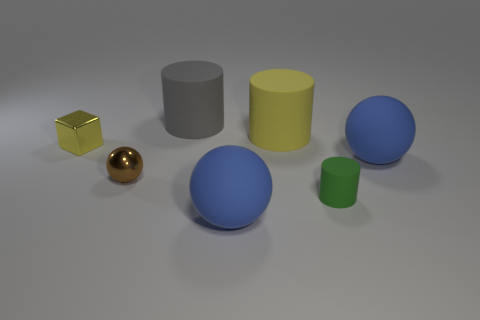The object that is the same color as the block is what size?
Make the answer very short. Large. Is there anything else that is the same size as the brown thing?
Your response must be concise. Yes. Is the tiny brown ball made of the same material as the green cylinder?
Provide a short and direct response. No. What number of objects are either big matte spheres that are behind the tiny green matte cylinder or small objects that are to the left of the gray rubber object?
Give a very brief answer. 3. Is there a cyan metal cylinder that has the same size as the green rubber object?
Give a very brief answer. No. There is a small thing that is the same shape as the large yellow rubber thing; what color is it?
Your answer should be compact. Green. Is there a tiny yellow metallic cube in front of the big blue rubber sphere in front of the metallic sphere?
Your response must be concise. No. There is a object in front of the small matte thing; does it have the same shape as the tiny green matte thing?
Ensure brevity in your answer.  No. What is the shape of the brown thing?
Give a very brief answer. Sphere. What number of tiny objects have the same material as the small cylinder?
Make the answer very short. 0. 